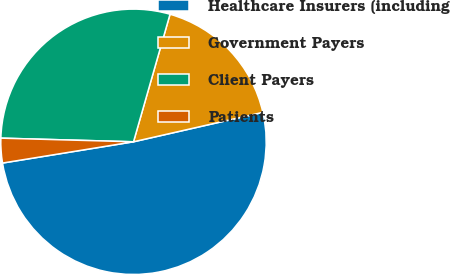<chart> <loc_0><loc_0><loc_500><loc_500><pie_chart><fcel>Healthcare Insurers (including<fcel>Government Payers<fcel>Client Payers<fcel>Patients<nl><fcel>51.0%<fcel>17.0%<fcel>29.0%<fcel>3.0%<nl></chart> 